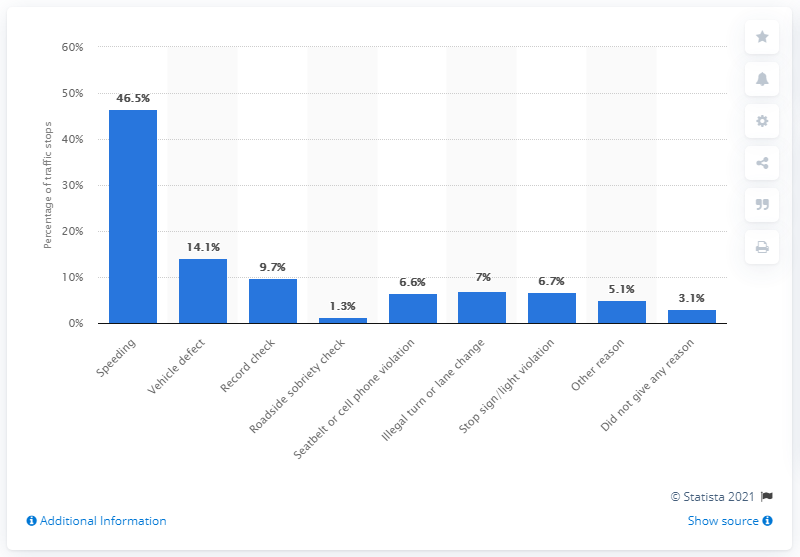Outline some significant characteristics in this image. In 2011, 46.5% of drivers were pulled over for speeding violations. 